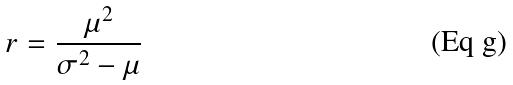Convert formula to latex. <formula><loc_0><loc_0><loc_500><loc_500>r = \frac { \mu ^ { 2 } } { \sigma ^ { 2 } - \mu }</formula> 